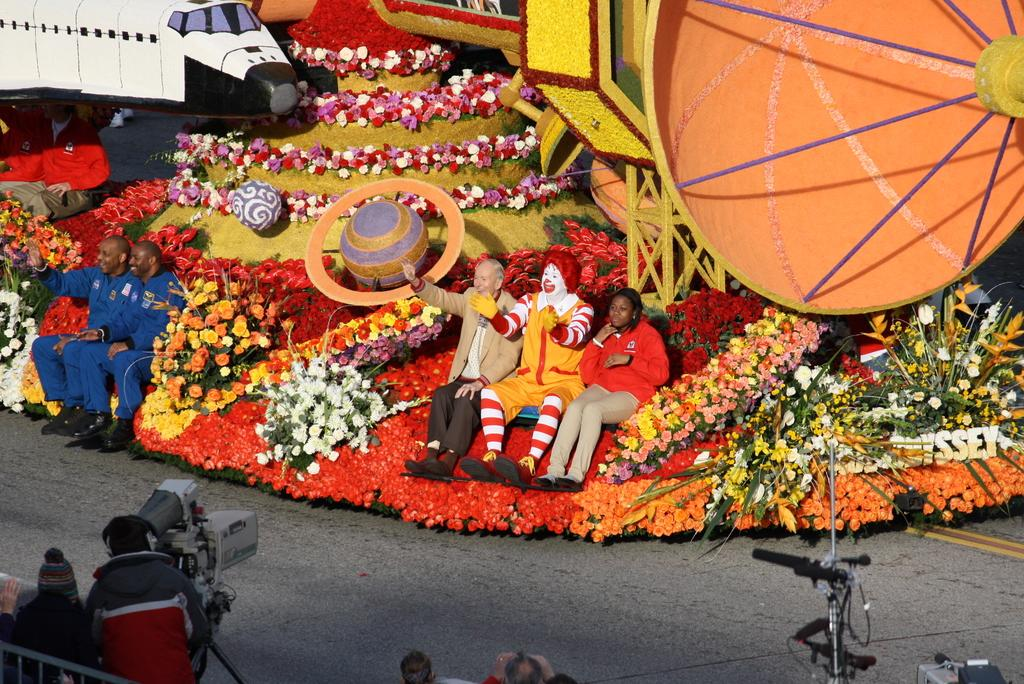What are the persons sitting on in the image? The persons are sitting on flowers in the image. What can be seen behind the sitting persons? There are objects and flowers behind the sitting persons. What is present in the image that is used for capturing images? There are cameras in the image. Are there any other persons visible in the image? Yes, there are additional persons in front of the sitting persons. What type of insurance policy do the flowers have in the image? The flowers do not have an insurance policy in the image, as insurance policies are not applicable to flowers. 